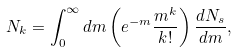Convert formula to latex. <formula><loc_0><loc_0><loc_500><loc_500>N _ { k } = \int _ { 0 } ^ { \infty } d m \left ( e ^ { - m } \frac { m ^ { k } } { k ! } \right ) \frac { d N _ { s } } { d m } ,</formula> 